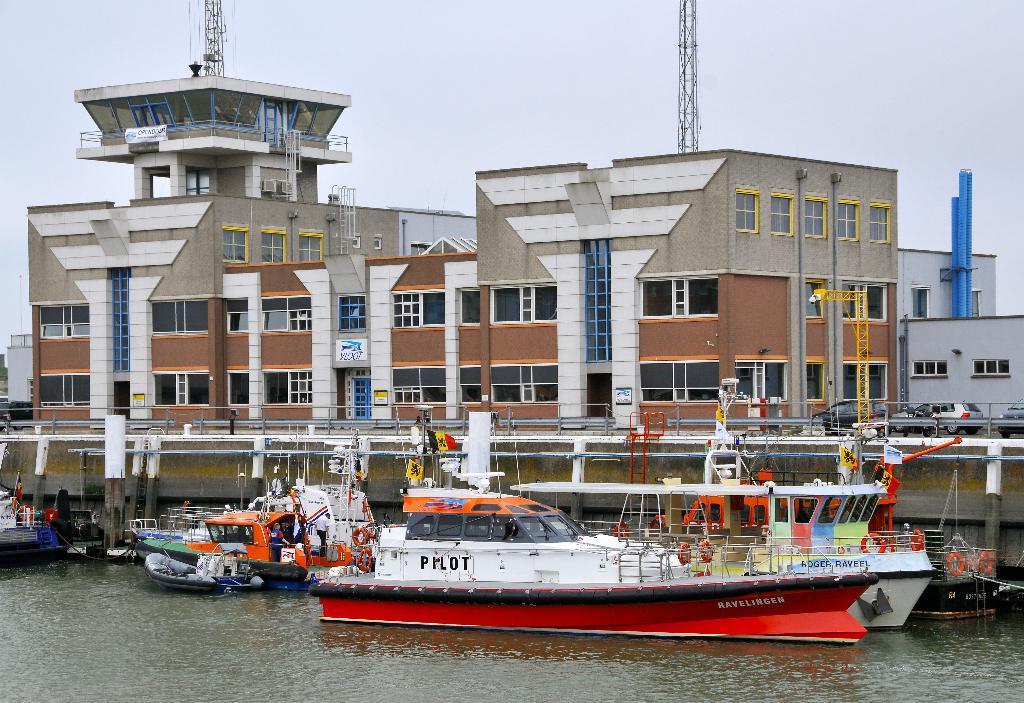How would you summarize this image in a sentence or two? In the foreground of this image, there are boats and a ship on the water. Behind it, there is railing, few buildings, poles and the sky. 